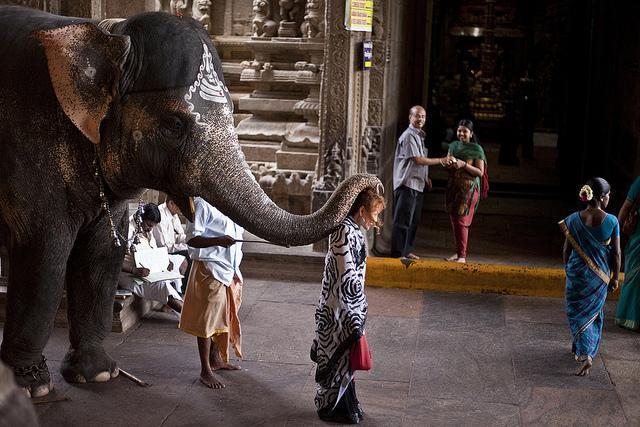What is the type of garment that the woman in blue is wearing?
Pick the correct solution from the four options below to address the question.
Options: Raincoat, chut thai, kimono, sari. Sari. 